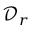Convert formula to latex. <formula><loc_0><loc_0><loc_500><loc_500>\mathcal { D } _ { r }</formula> 